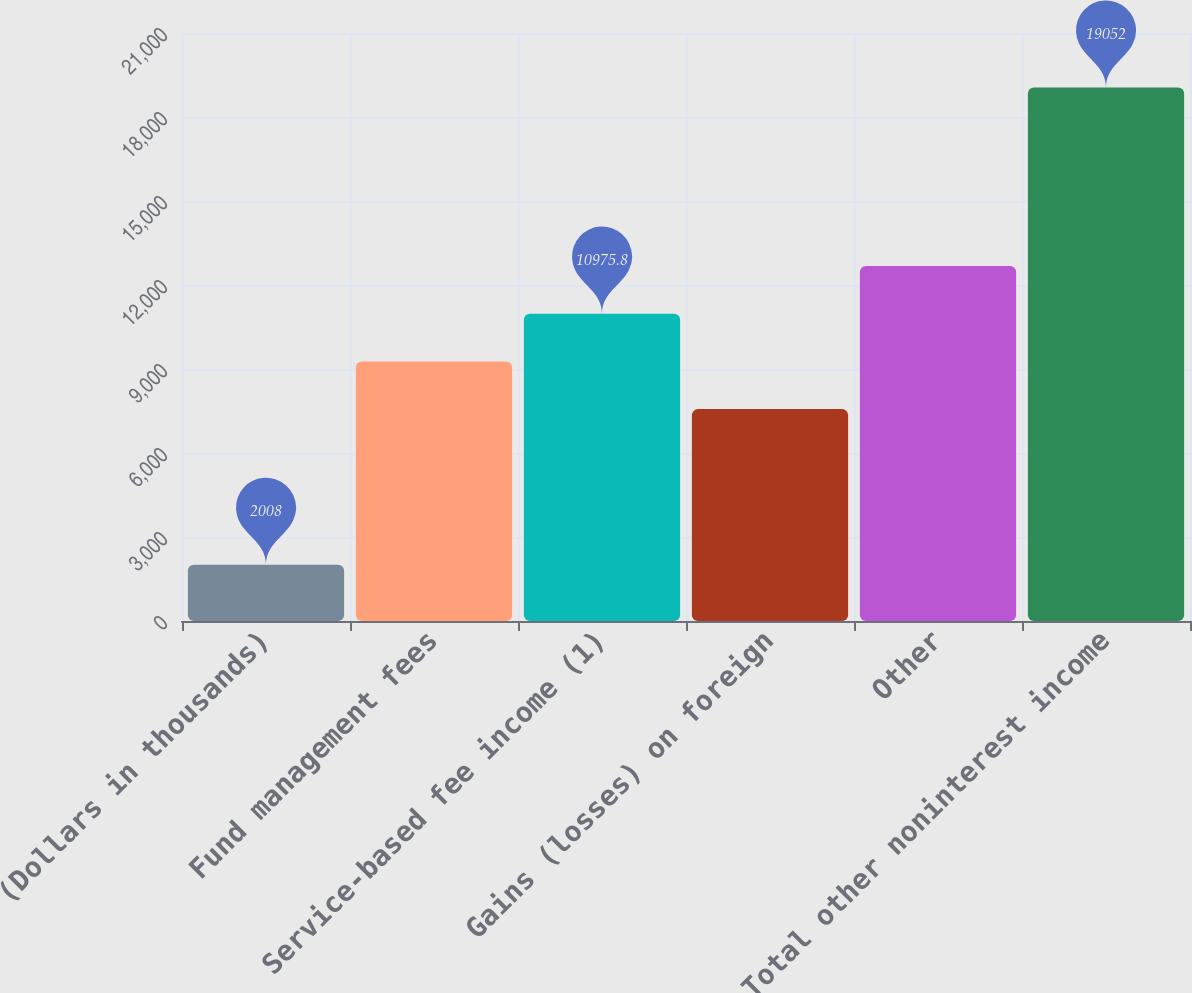Convert chart. <chart><loc_0><loc_0><loc_500><loc_500><bar_chart><fcel>(Dollars in thousands)<fcel>Fund management fees<fcel>Service-based fee income (1)<fcel>Gains (losses) on foreign<fcel>Other<fcel>Total other noninterest income<nl><fcel>2008<fcel>9271.4<fcel>10975.8<fcel>7567<fcel>12680.2<fcel>19052<nl></chart> 